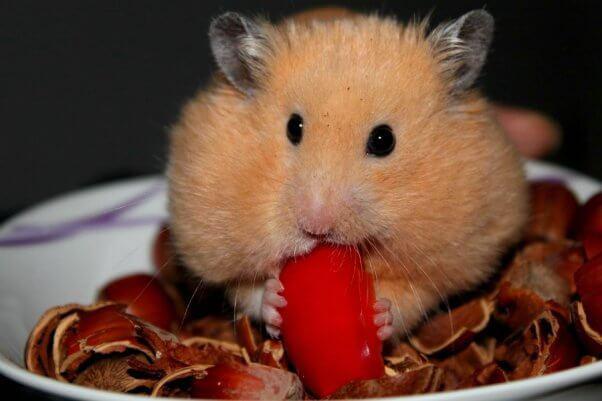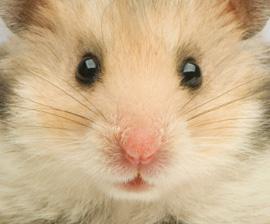The first image is the image on the left, the second image is the image on the right. Analyze the images presented: Is the assertion "At least one hamster is sitting in someone's hand." valid? Answer yes or no. No. 